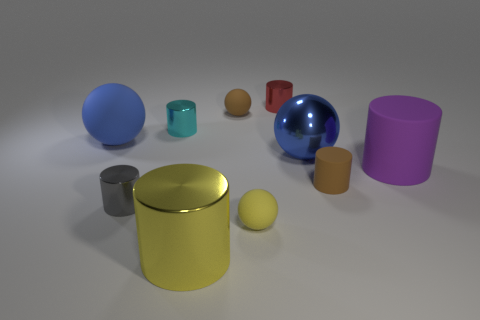How many objects are matte cylinders or big blue rubber things?
Make the answer very short. 3. There is a matte thing that is both to the left of the small yellow matte thing and to the right of the gray cylinder; what size is it?
Offer a very short reply. Small. What number of red cylinders are made of the same material as the small cyan thing?
Give a very brief answer. 1. The large sphere that is made of the same material as the purple thing is what color?
Provide a succinct answer. Blue. There is a large ball behind the blue metal ball; does it have the same color as the large rubber cylinder?
Ensure brevity in your answer.  No. There is a small yellow ball behind the big yellow thing; what is its material?
Your answer should be very brief. Rubber. Is the number of small yellow rubber balls in front of the yellow shiny thing the same as the number of green rubber cubes?
Your response must be concise. Yes. How many large things are the same color as the big rubber ball?
Your answer should be very brief. 1. What color is the other big metal thing that is the same shape as the red metallic thing?
Your response must be concise. Yellow. Is the size of the red cylinder the same as the brown matte cylinder?
Your response must be concise. Yes. 